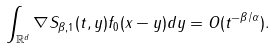<formula> <loc_0><loc_0><loc_500><loc_500>\int _ { \mathbb { R } ^ { d } } \nabla S _ { \beta , 1 } ( t , y ) f _ { 0 } ( x - y ) d y = O ( t ^ { - \beta / \alpha } ) .</formula> 